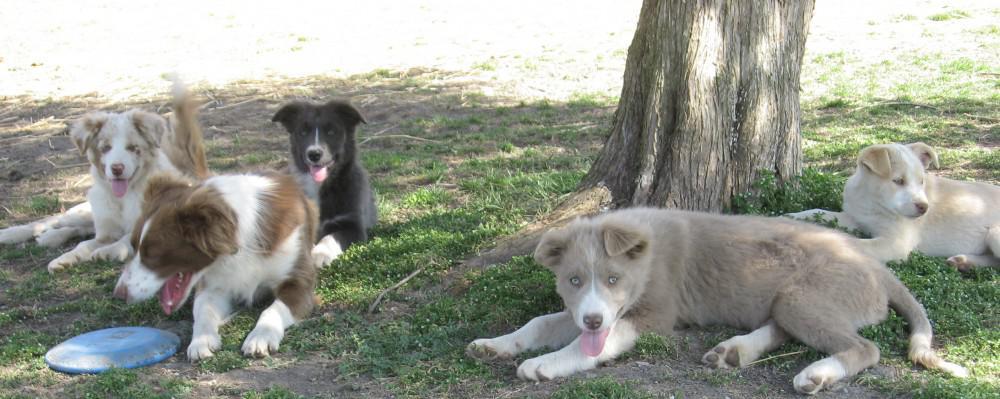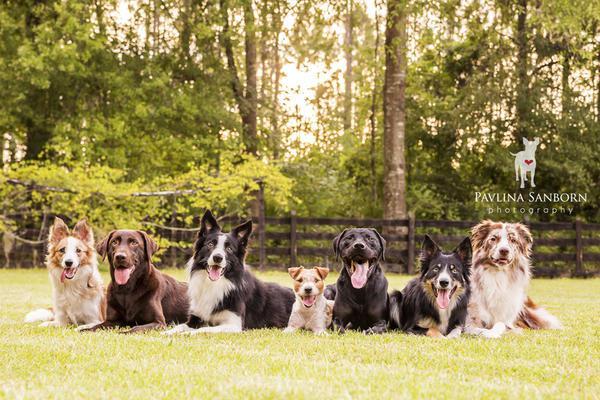The first image is the image on the left, the second image is the image on the right. Considering the images on both sides, is "There are at most 5 dogs on the left image." valid? Answer yes or no. Yes. The first image is the image on the left, the second image is the image on the right. For the images shown, is this caption "An image shows a straight row of at least seven dogs reclining on the grass." true? Answer yes or no. Yes. 